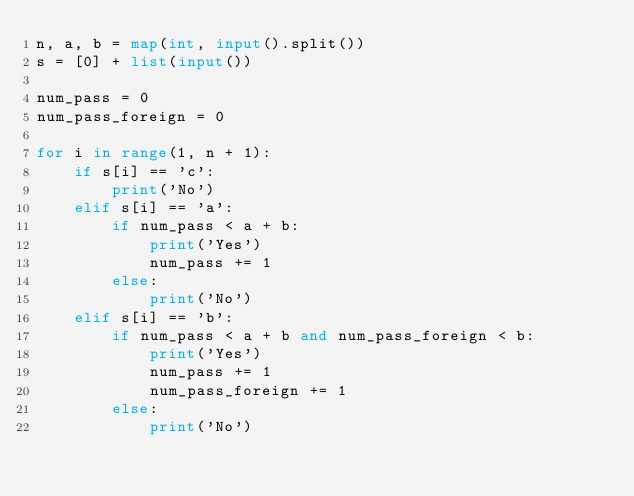Convert code to text. <code><loc_0><loc_0><loc_500><loc_500><_Python_>n, a, b = map(int, input().split())
s = [0] + list(input())

num_pass = 0
num_pass_foreign = 0

for i in range(1, n + 1):
	if s[i] == 'c':
		print('No')
	elif s[i] == 'a':
		if num_pass < a + b:
			print('Yes')
			num_pass += 1
		else:
			print('No')
	elif s[i] == 'b':
		if num_pass < a + b and num_pass_foreign < b:
			print('Yes')
			num_pass += 1
			num_pass_foreign += 1
		else:
			print('No')</code> 